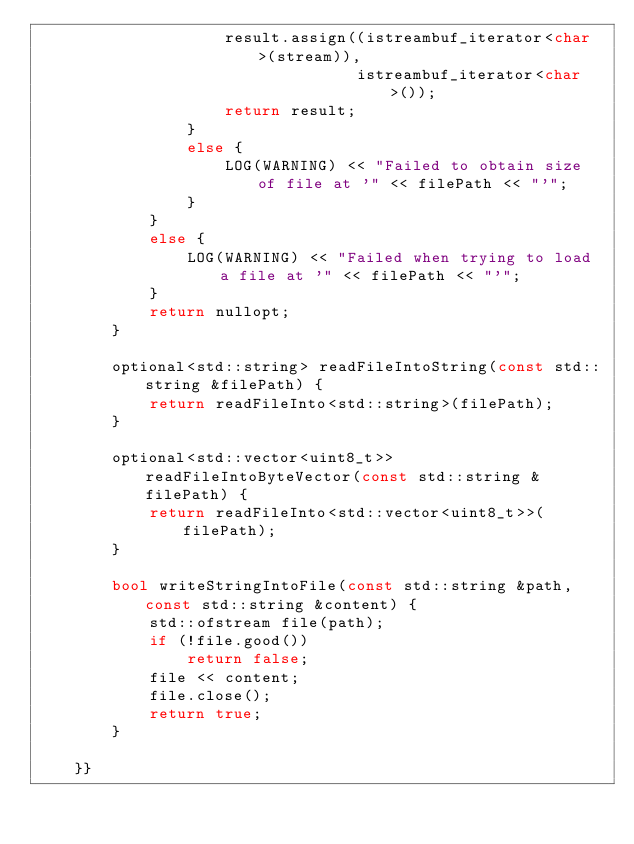<code> <loc_0><loc_0><loc_500><loc_500><_C++_>                    result.assign((istreambuf_iterator<char>(stream)),
                                  istreambuf_iterator<char>());
                    return result;
                }
                else {
                    LOG(WARNING) << "Failed to obtain size of file at '" << filePath << "'";
                }
            }
            else {
                LOG(WARNING) << "Failed when trying to load a file at '" << filePath << "'";
            }
            return nullopt;
        }

        optional<std::string> readFileIntoString(const std::string &filePath) {
            return readFileInto<std::string>(filePath);
        }

        optional<std::vector<uint8_t>> readFileIntoByteVector(const std::string &filePath) {
            return readFileInto<std::vector<uint8_t>>(filePath);
        }

        bool writeStringIntoFile(const std::string &path, const std::string &content) {
            std::ofstream file(path);
            if (!file.good())
                return false;
            file << content;
            file.close();
            return true;
        }

    }}</code> 